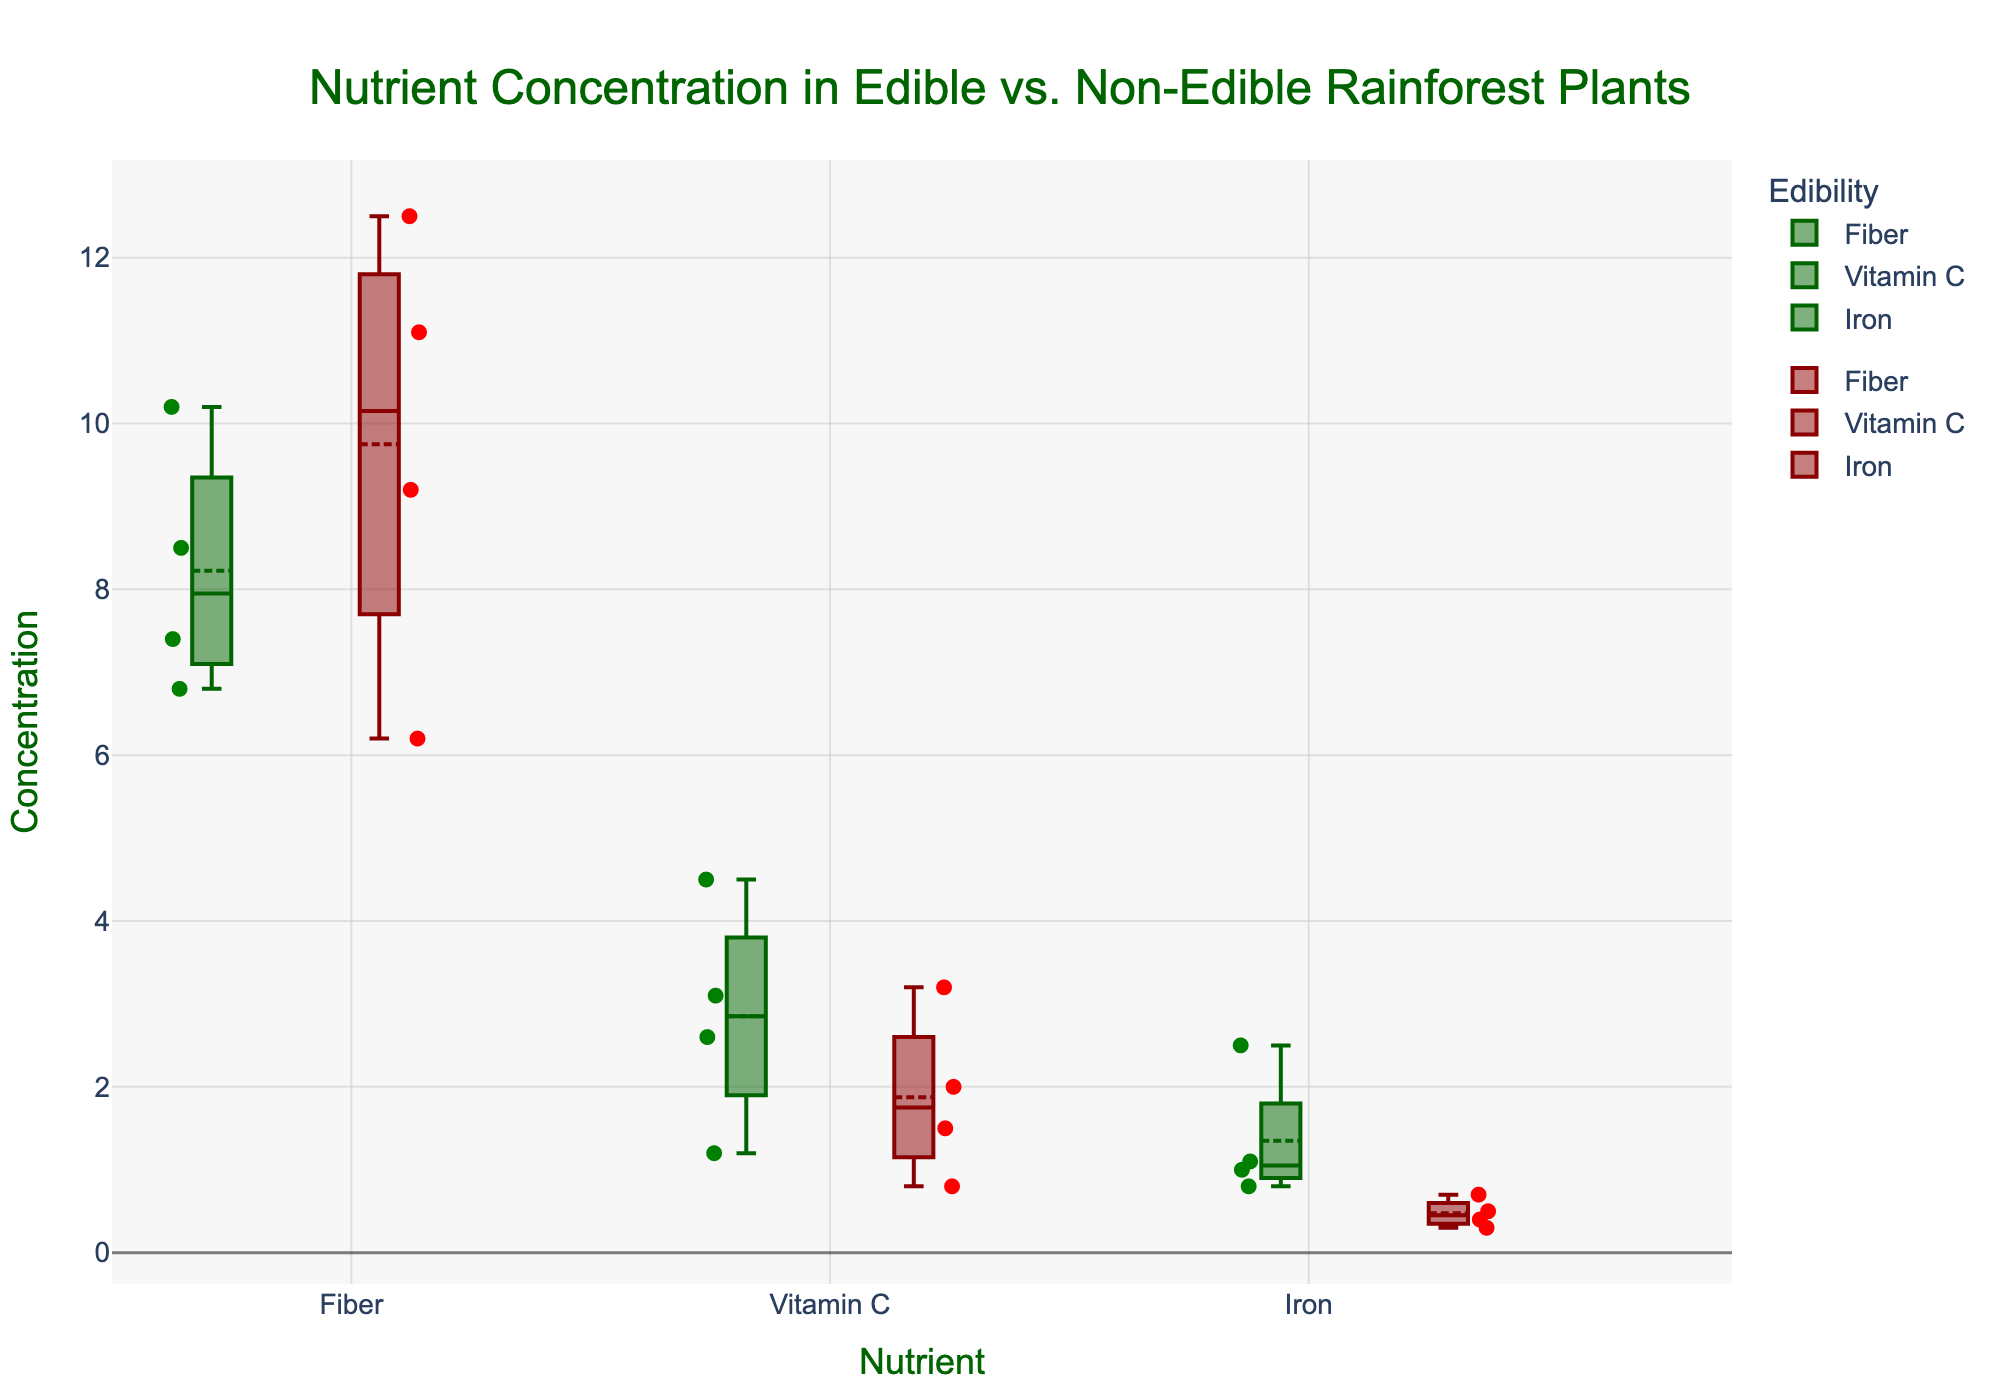What's the title of the figure? The title is displayed at the top center of the figure, indicating the subject of the plot.
Answer: Nutrient Concentration in Edible vs. Non-Edible Rainforest Plants How are the different plant types differentiated in the plot? The plant types are differentiated by color: green boxes represent edible plants, and red boxes represent non-edible plants.
Answer: By color What are the nutrients analyzed in this figure? The x-axis labels show the names of the nutrients being analyzed. These are the specific categories of nutrients measured.
Answer: Fiber, Vitamin C, Iron Which nutrient has the highest average concentration in edible plants? By looking at the boxplot for the edible plants (green) and observing the mean markers, we identify the nutrient with the highest average concentration.
Answer: Fiber What is the median concentration of Fiber in non-edible plants? The median is indicated by the line inside the box for each nutrient boxplot. For Fiber in non-edible plants, locate the red box and find the line inside it.
Answer: 10.2 Do edible or non-edible plants tend to have higher concentrations of Vitamin C? Compare the box plots for Vitamin C in both the green (edible) and red (non-edible) groups. The higher median value indicates a higher concentration.
Answer: Edible plants Which nutrient has the smallest spread in concentration for non-edible plants? The smallest spread is identified by looking at the size of the boxes. The smallest box on the red side indicates the nutrient with the smallest spread.
Answer: Iron Is there a nutrient where non-edible plants show a higher median concentration than edible plants? Compare the median lines in each boxplot for each nutrient. Identify any instance where the median line for a red boxplot is above the median line for the corresponding green boxplot.
Answer: Yes, Iron How does the concentration range of Fiber in edible plants compare to that in non-edible plants? Examine the length of the boxes and the whiskers for Fiber in both green (edible) and red (non-edible) boxplots to compare their ranges.
Answer: Wider range in edible plants Which nutrient shows the greatest difference in average concentration between edible and non-edible plants? Calculate the difference in mean values (indicated by the dots inside the box plots) between the green and red boxes for each nutrient. The nutrient with the largest difference is the answer.
Answer: Iron 